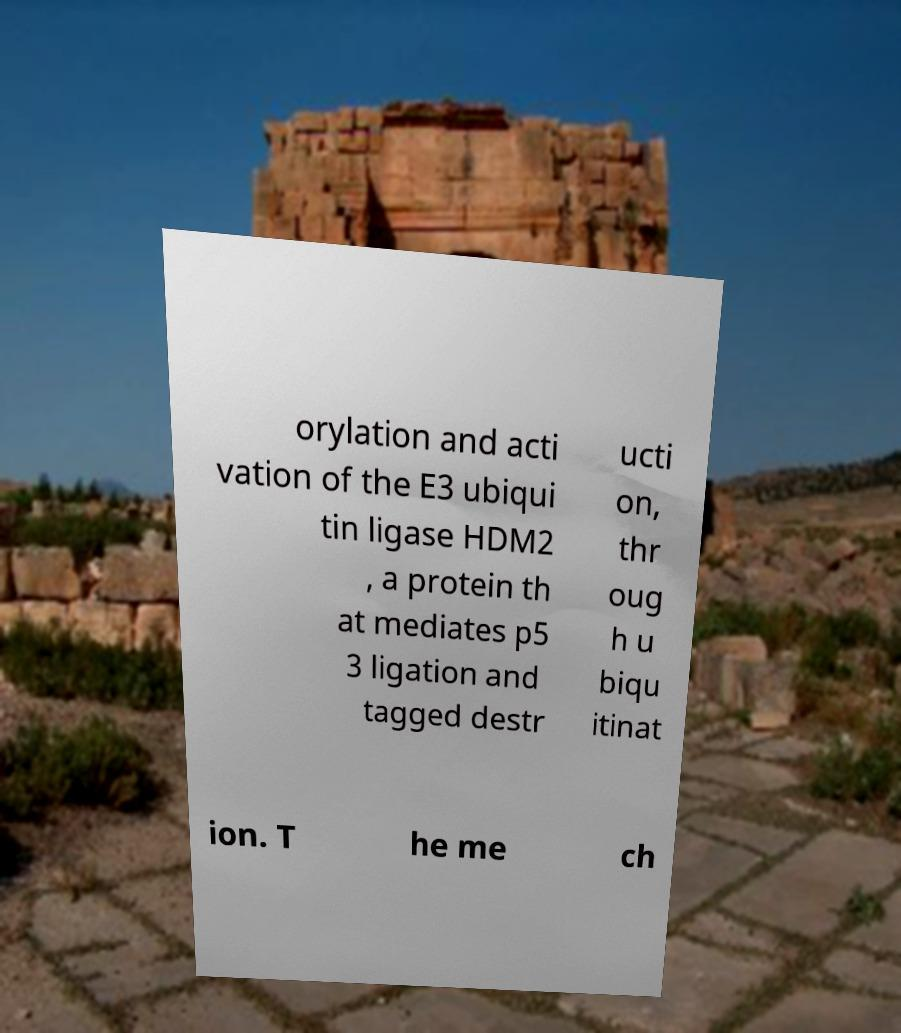Please identify and transcribe the text found in this image. orylation and acti vation of the E3 ubiqui tin ligase HDM2 , a protein th at mediates p5 3 ligation and tagged destr ucti on, thr oug h u biqu itinat ion. T he me ch 